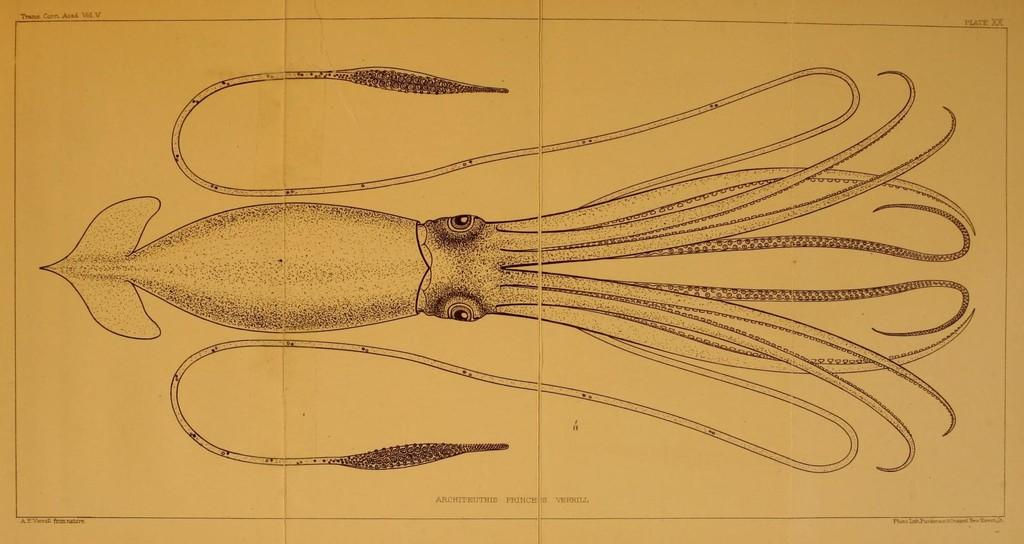What is the main subject of the drawing in the image? There is a drawing of an octopus in the image. How many potatoes are being powered by the crate in the image? There are no potatoes or crates present in the image; it features a drawing of an octopus. 